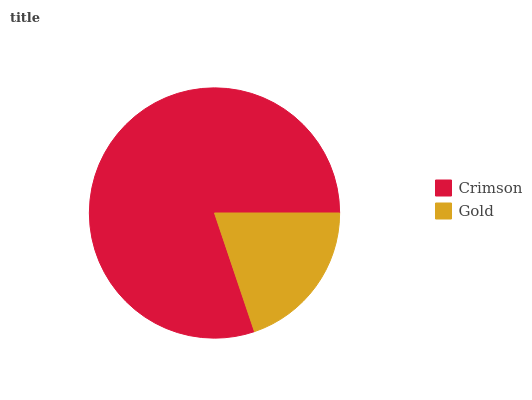Is Gold the minimum?
Answer yes or no. Yes. Is Crimson the maximum?
Answer yes or no. Yes. Is Gold the maximum?
Answer yes or no. No. Is Crimson greater than Gold?
Answer yes or no. Yes. Is Gold less than Crimson?
Answer yes or no. Yes. Is Gold greater than Crimson?
Answer yes or no. No. Is Crimson less than Gold?
Answer yes or no. No. Is Crimson the high median?
Answer yes or no. Yes. Is Gold the low median?
Answer yes or no. Yes. Is Gold the high median?
Answer yes or no. No. Is Crimson the low median?
Answer yes or no. No. 